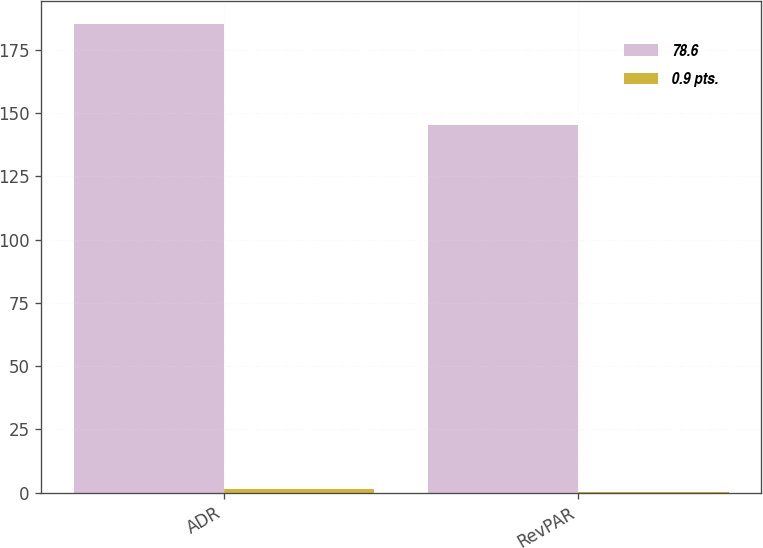<chart> <loc_0><loc_0><loc_500><loc_500><stacked_bar_chart><ecel><fcel>ADR<fcel>RevPAR<nl><fcel>78.6<fcel>185.18<fcel>145.49<nl><fcel>0.9 pts.<fcel>1.4<fcel>0.3<nl></chart> 